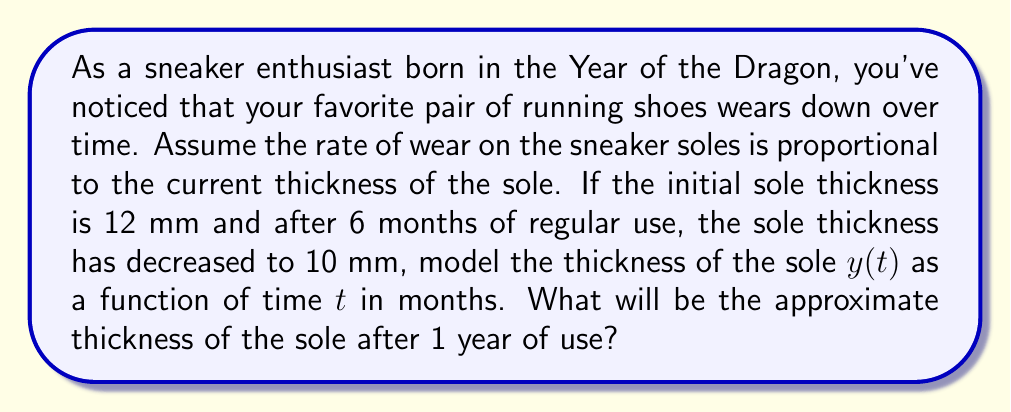Show me your answer to this math problem. Let's approach this step-by-step:

1) We can model this situation using the differential equation:

   $$\frac{dy}{dt} = -ky$$

   where $y$ is the thickness of the sole, $t$ is time in months, and $k$ is a constant representing the rate of wear.

2) The general solution to this differential equation is:

   $$y(t) = y_0e^{-kt}$$

   where $y_0$ is the initial thickness.

3) We know that:
   - $y_0 = 12$ mm (initial thickness)
   - At $t = 6$ months, $y = 10$ mm

4) Let's substitute these values into our general solution:

   $$10 = 12e^{-6k}$$

5) Solving for $k$:

   $$\frac{10}{12} = e^{-6k}$$
   $$\ln(\frac{10}{12}) = -6k$$
   $$k = -\frac{1}{6}\ln(\frac{10}{12}) \approx 0.0318$$

6) Now that we have $k$, we can write our specific solution:

   $$y(t) = 12e^{-0.0318t}$$

7) To find the thickness after 1 year (12 months), we substitute $t = 12$:

   $$y(12) = 12e^{-0.0318(12)} \approx 8.37$$

Therefore, after 1 year, the sole thickness will be approximately 8.37 mm.
Answer: $8.37$ mm 